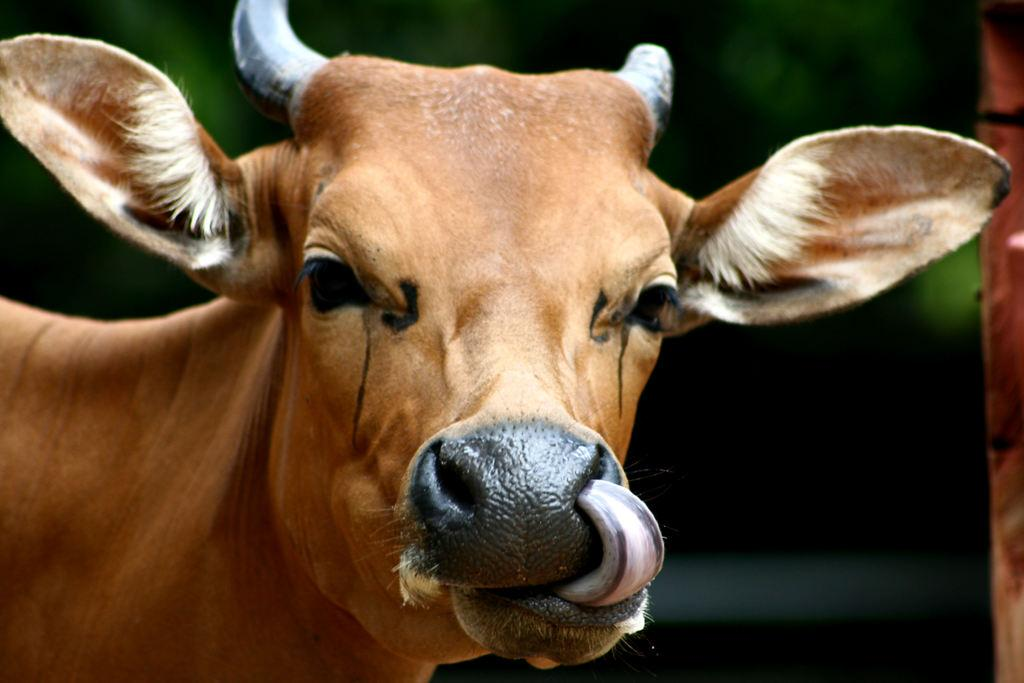What animal is the main subject of the image? There is a cow in the image. Can you describe the cow's coloring? The cow has brown, black, and cream coloring. How would you describe the background of the image? The background of the image is blurry. What colors are present in the background? The background has green and black colors. What is the purpose of the crate in the image? There is no crate present in the image. How does the cow's mind process information in the image? The image does not provide any information about the cow's mental processes or how it processes information. 